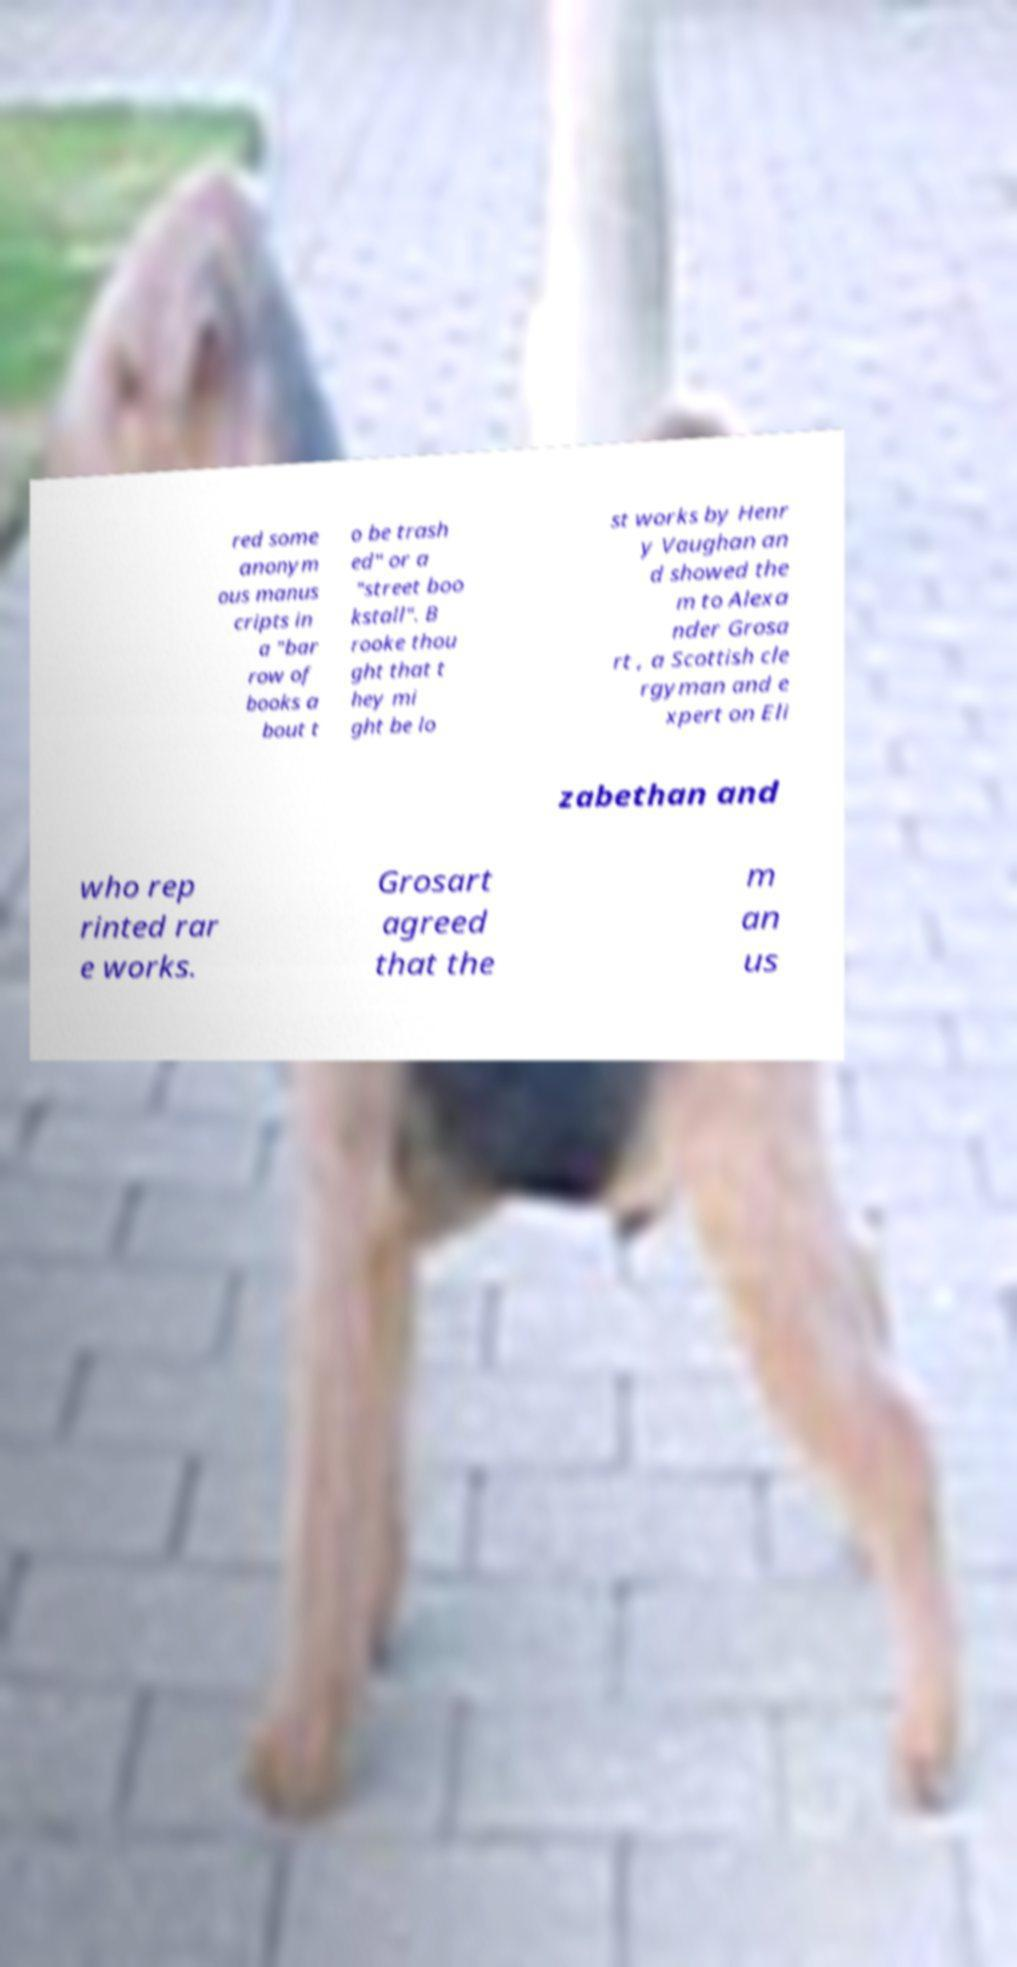I need the written content from this picture converted into text. Can you do that? red some anonym ous manus cripts in a "bar row of books a bout t o be trash ed" or a "street boo kstall". B rooke thou ght that t hey mi ght be lo st works by Henr y Vaughan an d showed the m to Alexa nder Grosa rt , a Scottish cle rgyman and e xpert on Eli zabethan and who rep rinted rar e works. Grosart agreed that the m an us 